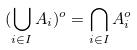Convert formula to latex. <formula><loc_0><loc_0><loc_500><loc_500>( \bigcup _ { i \in I } A _ { i } ) ^ { o } = \bigcap _ { i \in I } A _ { i } ^ { o }</formula> 